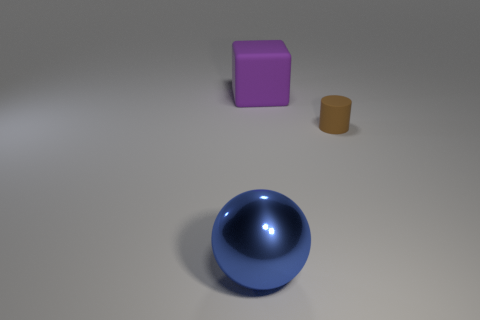Is there any other thing that is the same material as the brown thing?
Your answer should be very brief. Yes. There is a blue ball; is its size the same as the object right of the big purple thing?
Provide a succinct answer. No. There is a object that is both on the left side of the tiny thing and in front of the large purple rubber cube; how big is it?
Offer a terse response. Large. Are there the same number of brown matte cylinders that are to the left of the large metal sphere and large cubes?
Your response must be concise. No. Is there any other thing that has the same size as the brown matte cylinder?
Provide a short and direct response. No. What shape is the matte thing behind the matte cylinder that is right of the purple block?
Your answer should be compact. Cube. Is the brown thing to the right of the purple cube made of the same material as the purple block?
Ensure brevity in your answer.  Yes. Is the number of tiny brown rubber cylinders behind the purple thing the same as the number of objects that are in front of the small thing?
Your answer should be very brief. No. There is a big object that is on the left side of the big rubber object; how many cylinders are behind it?
Your response must be concise. 1. There is a purple cube that is the same size as the blue metallic thing; what material is it?
Your response must be concise. Rubber. 